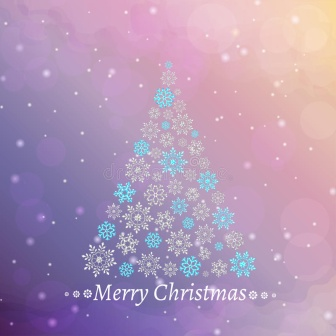Describe a realistic scenario where this image might be displayed outdoors. This image could be part of a festive outdoor display, perhaps printed on a large, weather-resistant banner. It could be hung at the entrance of a community park hosting a Christmas fair, welcoming visitors with its festive cheer. The vibrant colors and elegant design would stand out against the wintry landscape, easily catching the eyes of passersby. Snow gently falling around the banner would add to the scene, creating a magical experience for everyone attending the fair, where people enjoy hot drinks, browse holiday stalls, and participate in fun activities. 